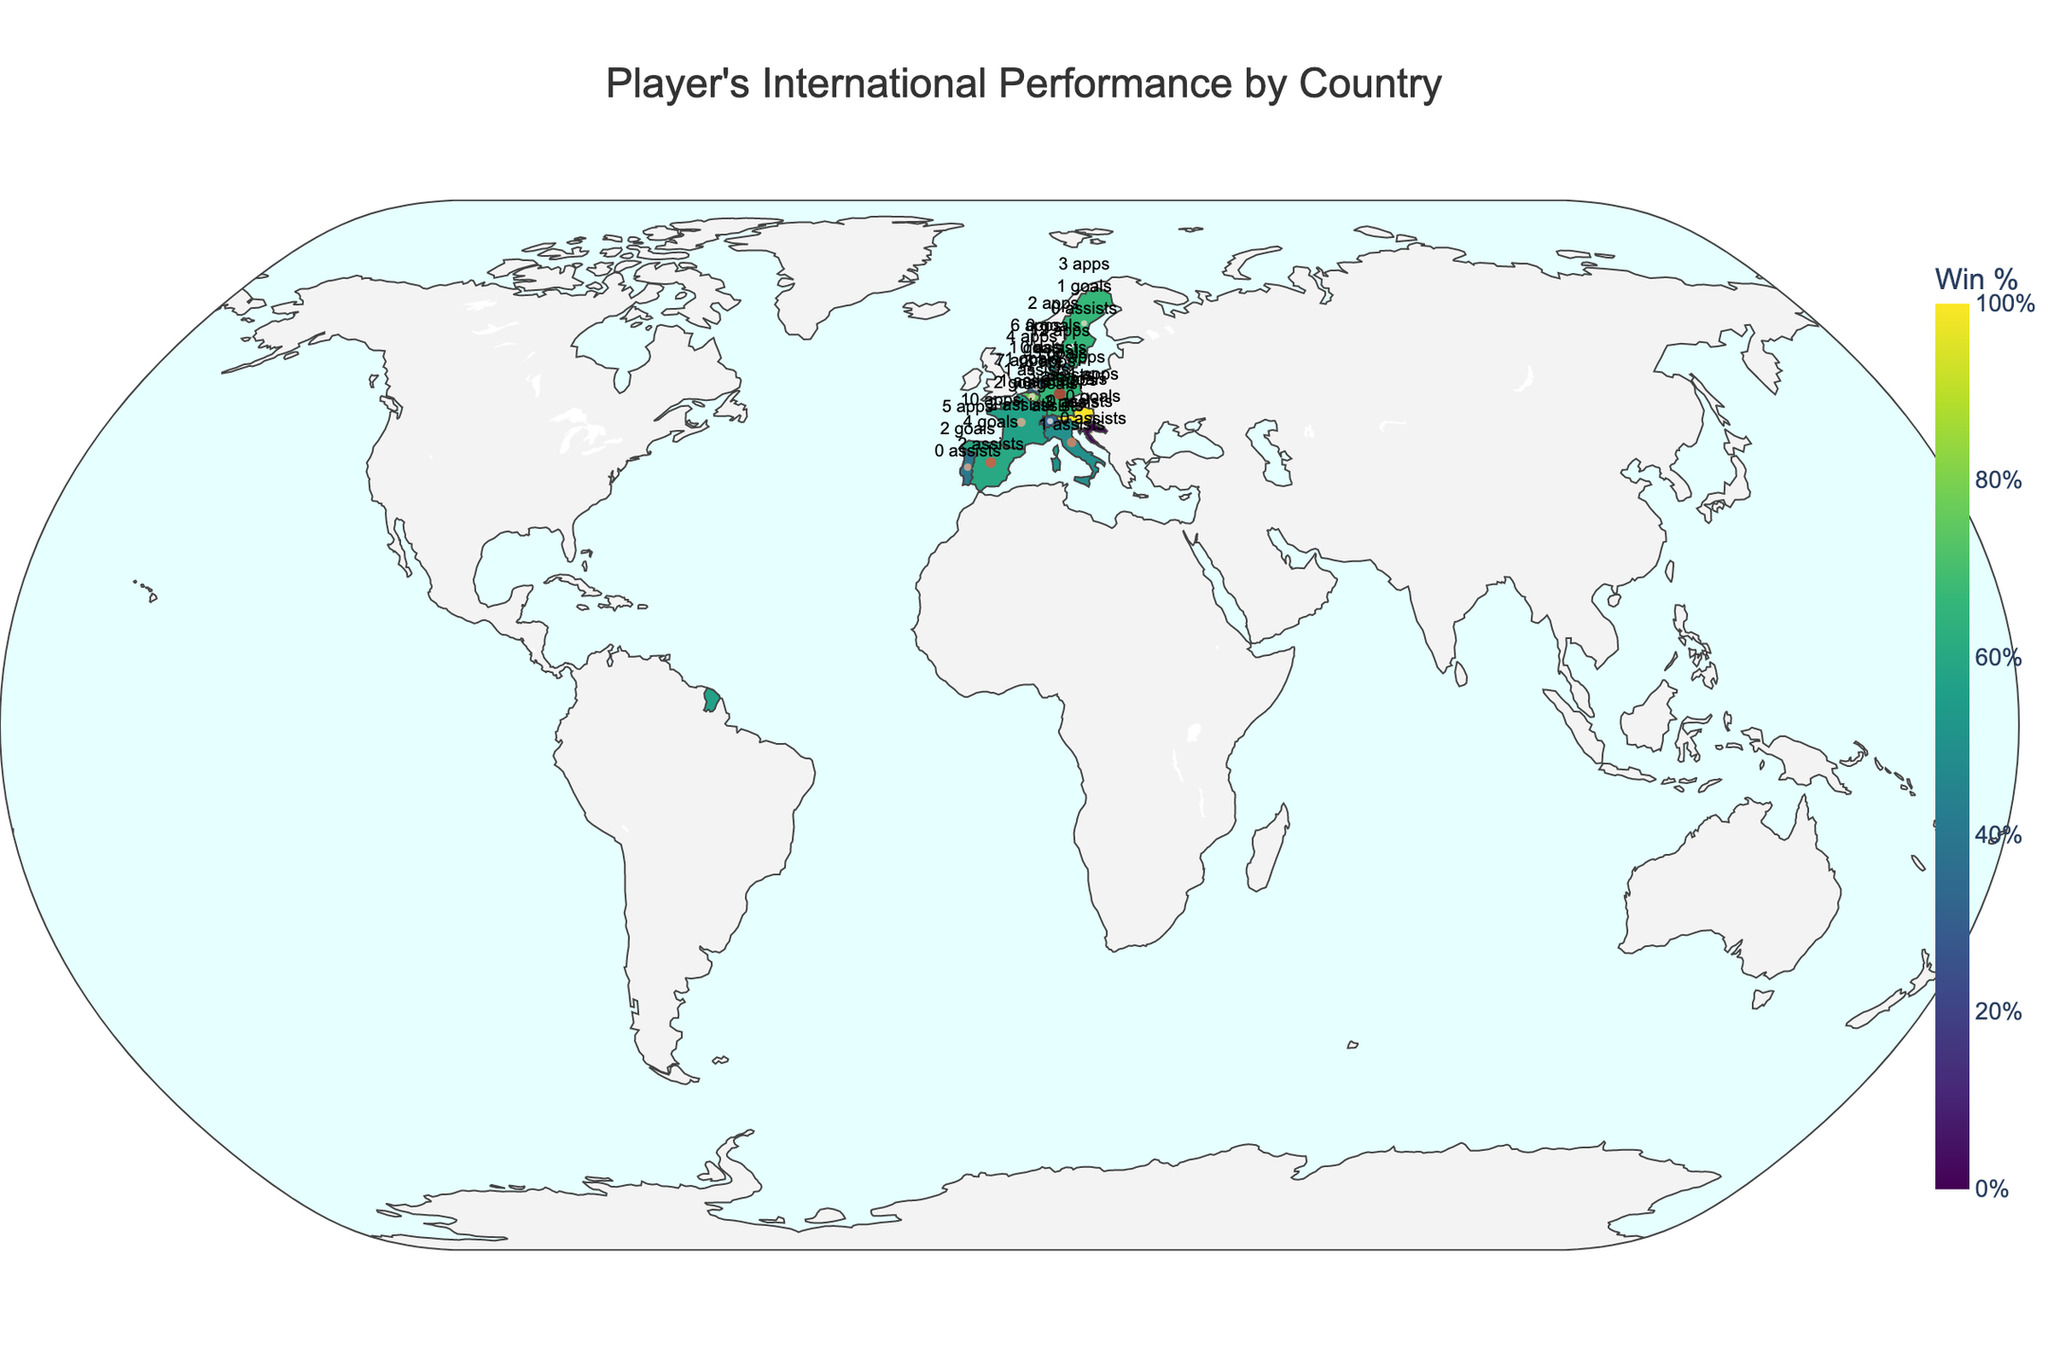What is the title of the plot? The title of a plot is usually displayed at the top in larger font. In this case, look at the top center of the figure to find the title.
Answer: Player's International Performance by Country Which country has the highest win percentage and what is it? Observe the color shading and the hover information of each country on the map. The darkest shade indicating the highest percentage is Austria.
Answer: Austria, 100% How many appearances did the player make in Germany? Hover over Germany on the map to see detailed statistics including appearances. Germany shows 12 appearances.
Answer: 12 Which country did the player score the most goals in, and how many goals were there? Hover over each country to see the goal statistics. The highest number of goals is in England, where the player scored 7 goals.
Answer: England, 7 What is the win percentage for the player's appearances in Spain? Hover over Spain to view the detailed statistics, including the win percentage. Spain has a win percentage of 60.0%.
Answer: 60.0% In which country did the player make the fewest appearances, and how many? Look for the country with the smallest circle representing the fewest appearances. Croatia has the smallest circle with 1 appearance.
Answer: Croatia, 1 How many total goals did the player score across all countries? Add the goals from each country [(7+5+4+3+2+1+2+1+0+1+0+1+0)] to get the total.
Answer: 27 Compare the number of assists in France and Portugal. Which country has more assists? Hover over France and Portugal to compare assists. France has 2 assists, while Portugal has 0 assists. Hence, France has more assists.
Answer: France How does the player's performance in terms of win percentage in Belgium compare to France? Hover over Belgium and France to see the win percentages. Belgium has a win percentage of 75.0%, while France has 57.1%. Thus, Belgium has a higher win percentage.
Answer: Belgium has a higher win percentage Which color scale is used to represent win percentage in the map? Observe the color gradient bar on the right side representing the win percentage. It shows a Viridis color scale ranging from lighter to darker shades.
Answer: Viridis 